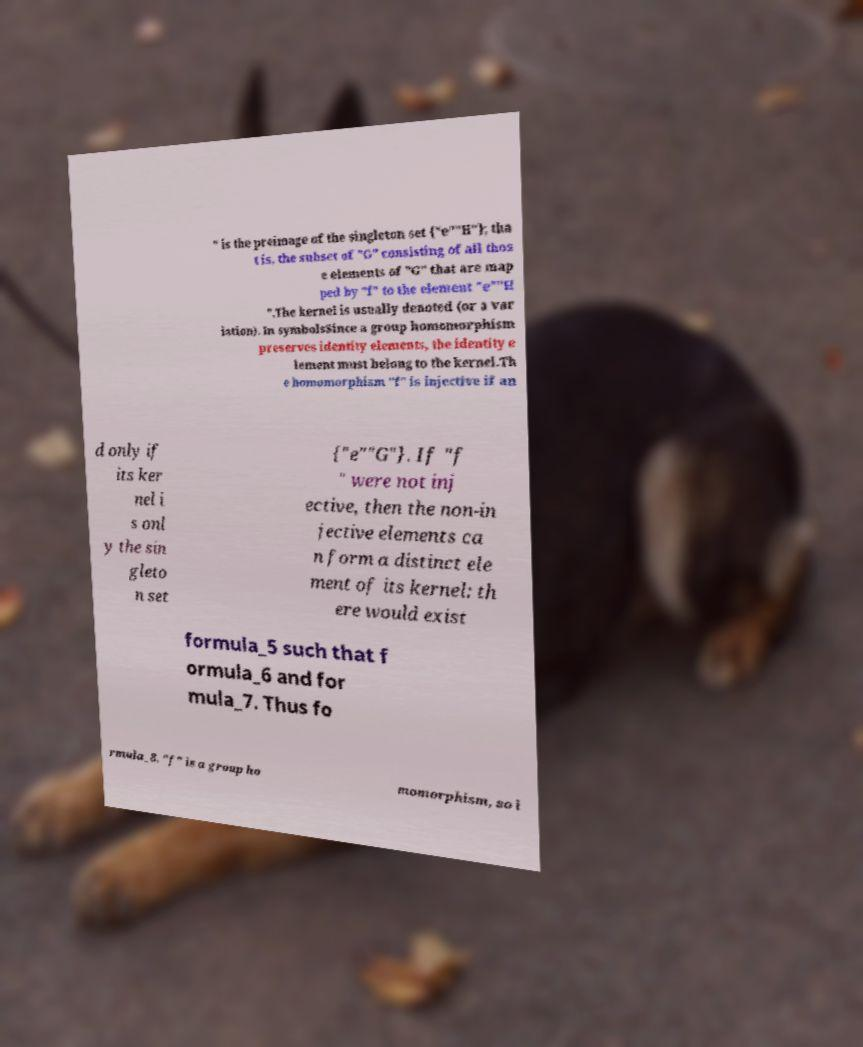Could you assist in decoding the text presented in this image and type it out clearly? " is the preimage of the singleton set {"e""H"}; tha t is, the subset of "G" consisting of all thos e elements of "G" that are map ped by "f" to the element "e""H ".The kernel is usually denoted (or a var iation). In symbolsSince a group homomorphism preserves identity elements, the identity e lement must belong to the kernel.Th e homomorphism "f" is injective if an d only if its ker nel i s onl y the sin gleto n set {"e""G"}. If "f " were not inj ective, then the non-in jective elements ca n form a distinct ele ment of its kernel: th ere would exist formula_5 such that f ormula_6 and for mula_7. Thus fo rmula_8. "f" is a group ho momorphism, so i 